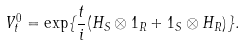<formula> <loc_0><loc_0><loc_500><loc_500>V _ { t } ^ { 0 } = \exp \{ { \frac { t } { i } } ( H _ { S } \otimes 1 _ { R } + 1 _ { S } \otimes H _ { R } ) \} .</formula> 